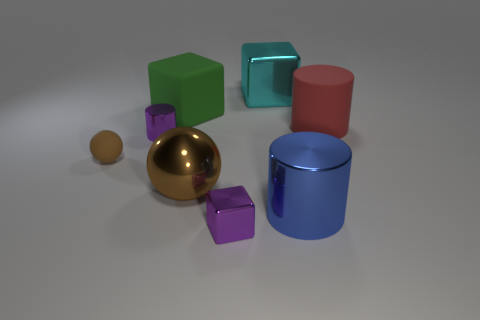Add 1 cubes. How many objects exist? 9 Subtract all cylinders. How many objects are left? 5 Add 8 tiny brown rubber balls. How many tiny brown rubber balls exist? 9 Subtract 0 red spheres. How many objects are left? 8 Subtract all small metallic cubes. Subtract all big blue metallic cylinders. How many objects are left? 6 Add 2 cyan metal cubes. How many cyan metal cubes are left? 3 